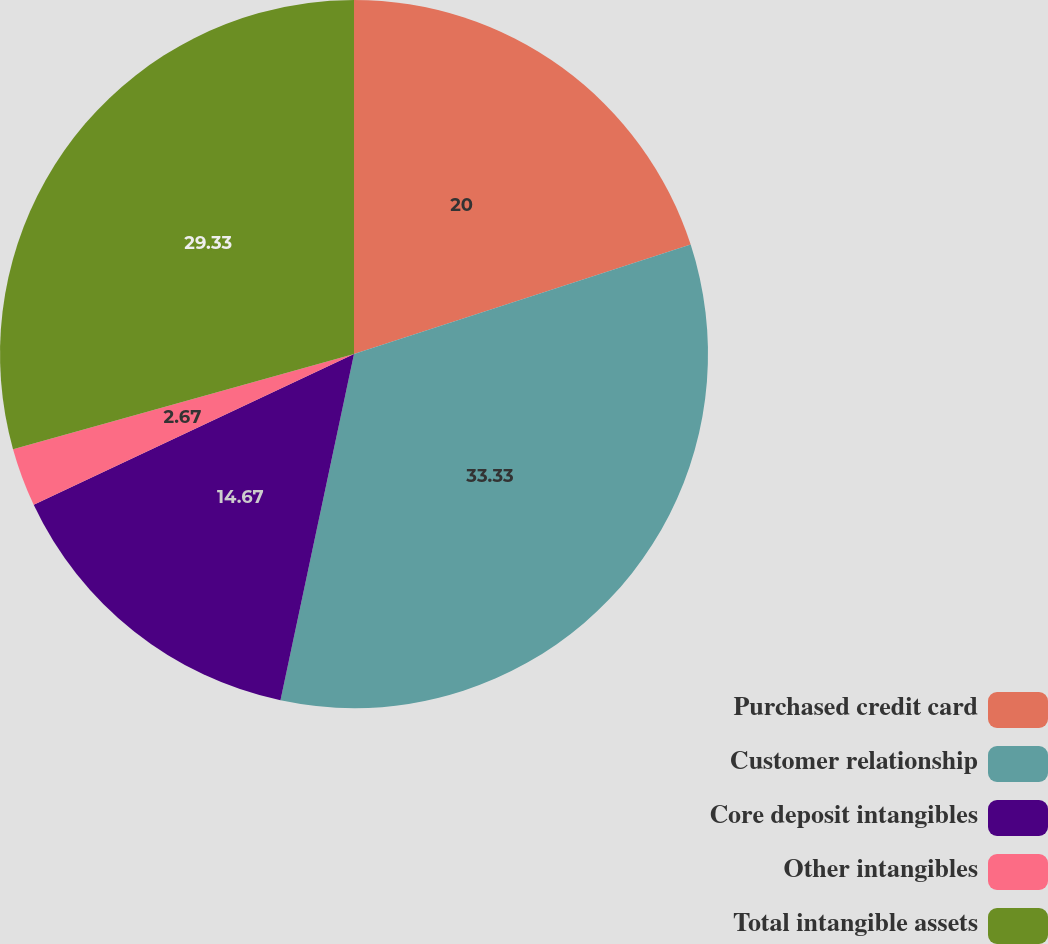Convert chart. <chart><loc_0><loc_0><loc_500><loc_500><pie_chart><fcel>Purchased credit card<fcel>Customer relationship<fcel>Core deposit intangibles<fcel>Other intangibles<fcel>Total intangible assets<nl><fcel>20.0%<fcel>33.33%<fcel>14.67%<fcel>2.67%<fcel>29.33%<nl></chart> 